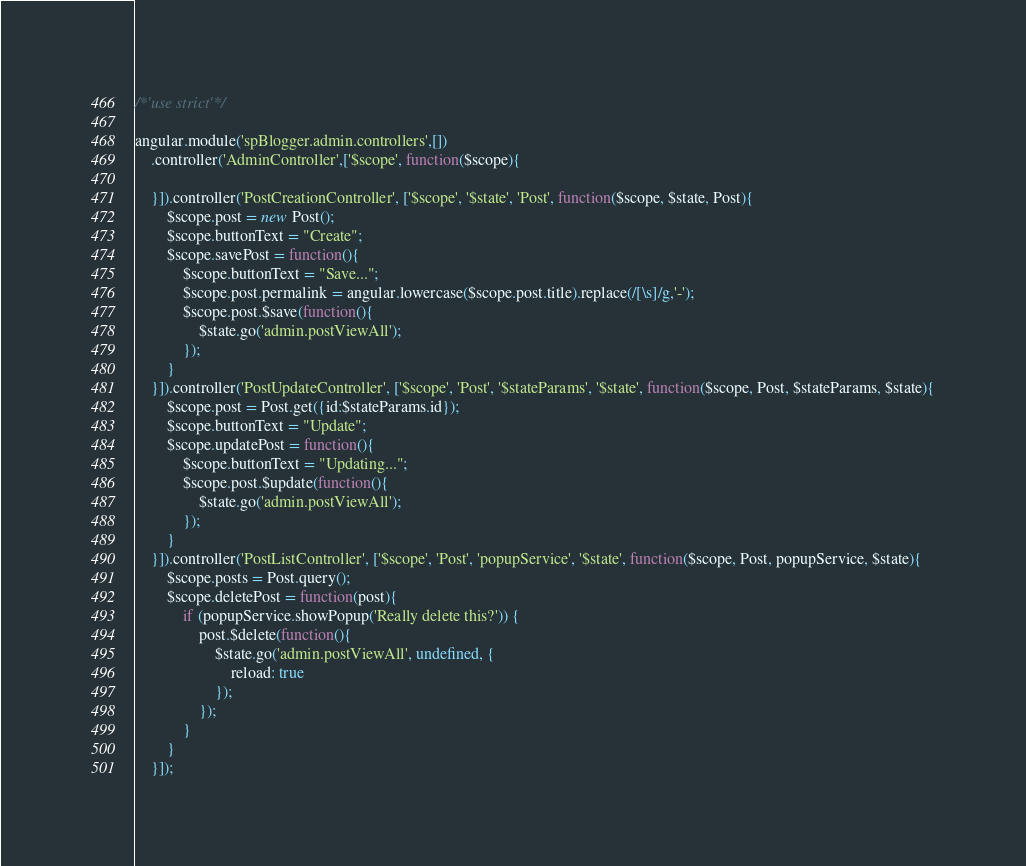<code> <loc_0><loc_0><loc_500><loc_500><_JavaScript_>/*'use strict'*/

angular.module('spBlogger.admin.controllers',[])
    .controller('AdminController',['$scope', function($scope){

    }]).controller('PostCreationController', ['$scope', '$state', 'Post', function($scope, $state, Post){
    	$scope.post = new Post();
    	$scope.buttonText = "Create";
    	$scope.savePost = function(){
    		$scope.buttonText = "Save...";
    		$scope.post.permalink = angular.lowercase($scope.post.title).replace(/[\s]/g,'-');
    		$scope.post.$save(function(){
    			$state.go('admin.postViewAll');
    		});
    	}
    }]).controller('PostUpdateController', ['$scope', 'Post', '$stateParams', '$state', function($scope, Post, $stateParams, $state){
    	$scope.post = Post.get({id:$stateParams.id});
    	$scope.buttonText = "Update";
    	$scope.updatePost = function(){
    		$scope.buttonText = "Updating...";
    		$scope.post.$update(function(){
    			$state.go('admin.postViewAll');
    		});
    	}
    }]).controller('PostListController', ['$scope', 'Post', 'popupService', '$state', function($scope, Post, popupService, $state){
    	$scope.posts = Post.query();
    	$scope.deletePost = function(post){
    		if (popupService.showPopup('Really delete this?')) {
    			post.$delete(function(){
    				$state.go('admin.postViewAll', undefined, {
    					reload: true
    				});
    			});
    		}
    	}
    }]);</code> 